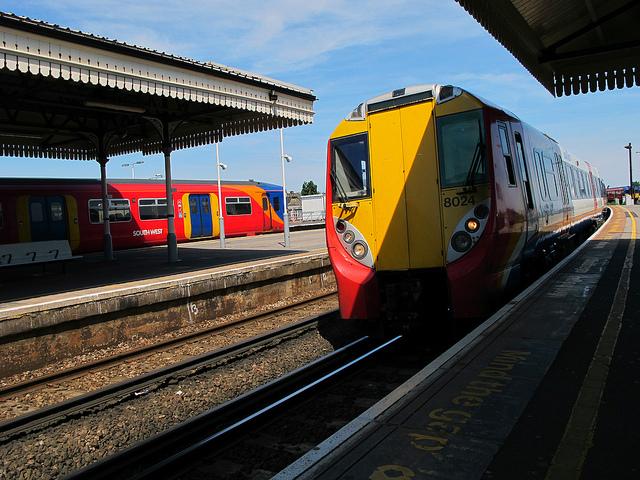How many trains on the track?
Write a very short answer. 2. How many trains are in the photo?
Answer briefly. 2. What color are the train cars?
Keep it brief. Yellow and red. Where is the train coming from?
Be succinct. Tracks. What color is the front of the train?
Keep it brief. Yellow. How many street poles?
Be succinct. 3. 